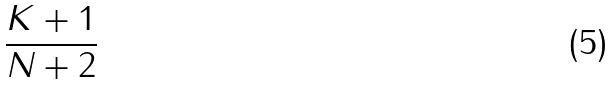<formula> <loc_0><loc_0><loc_500><loc_500>\frac { K + 1 } { N + 2 }</formula> 